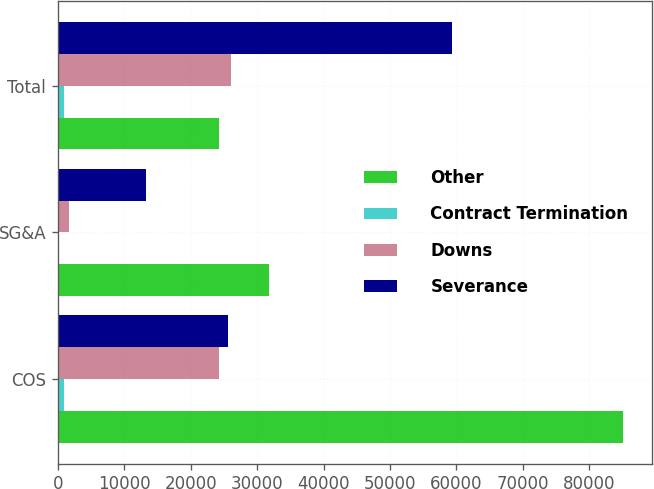Convert chart. <chart><loc_0><loc_0><loc_500><loc_500><stacked_bar_chart><ecel><fcel>COS<fcel>SG&A<fcel>Total<nl><fcel>Other<fcel>85160<fcel>31745<fcel>24335<nl><fcel>Contract Termination<fcel>907<fcel>43<fcel>950<nl><fcel>Downs<fcel>24335<fcel>1689<fcel>26024<nl><fcel>Severance<fcel>25665<fcel>13205<fcel>59370<nl></chart> 